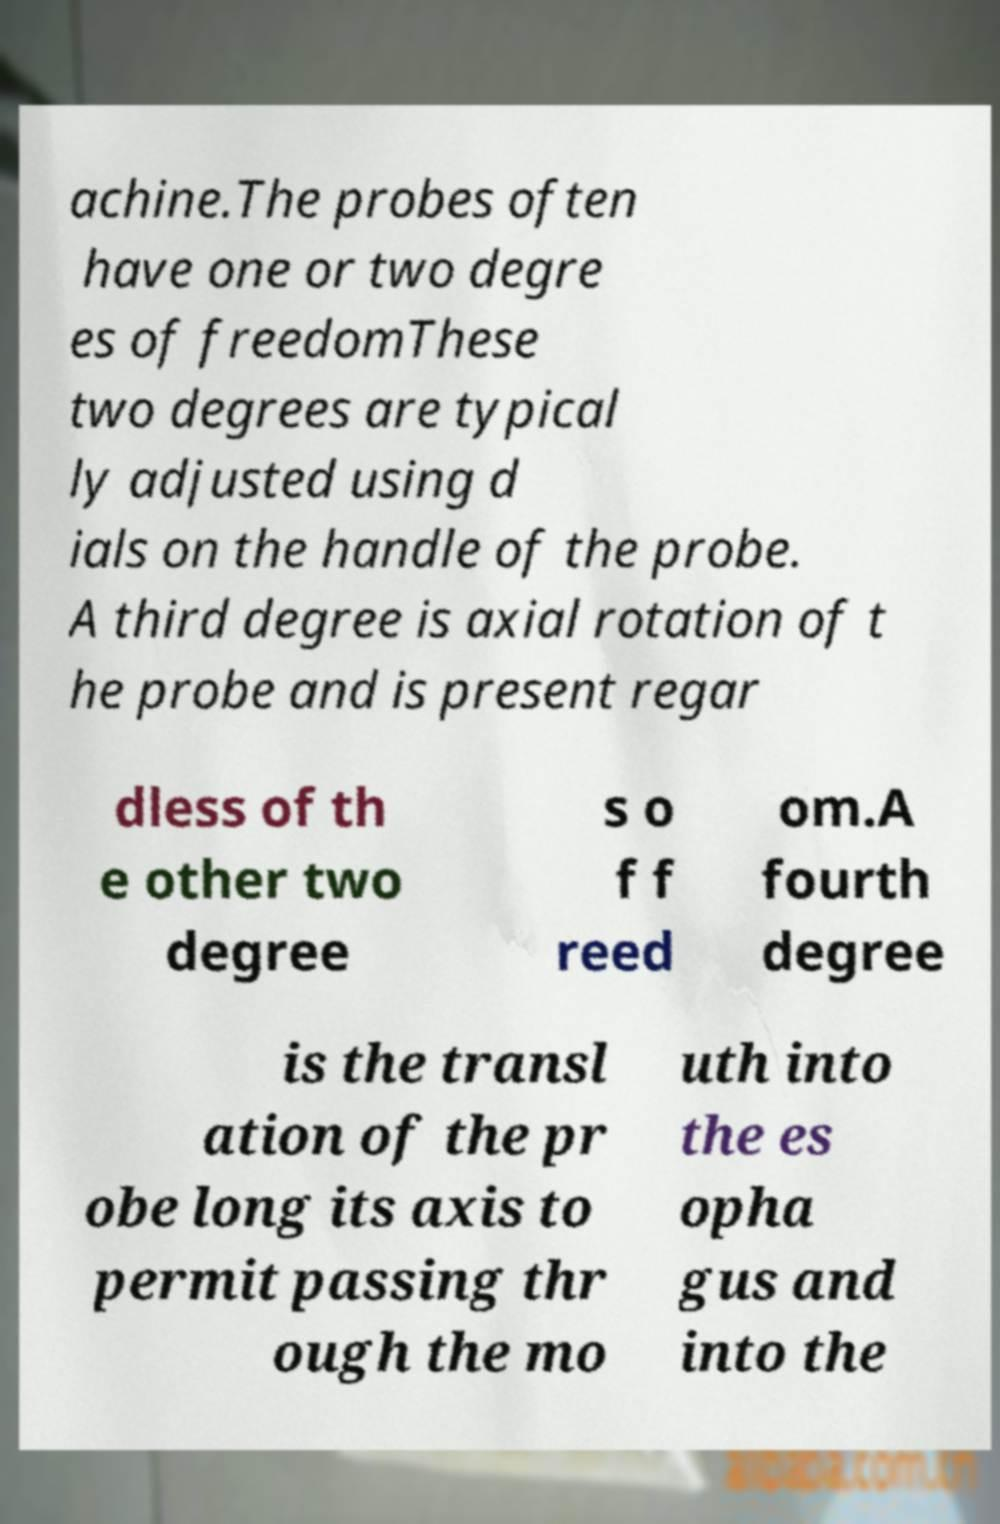Can you read and provide the text displayed in the image?This photo seems to have some interesting text. Can you extract and type it out for me? achine.The probes often have one or two degre es of freedomThese two degrees are typical ly adjusted using d ials on the handle of the probe. A third degree is axial rotation of t he probe and is present regar dless of th e other two degree s o f f reed om.A fourth degree is the transl ation of the pr obe long its axis to permit passing thr ough the mo uth into the es opha gus and into the 